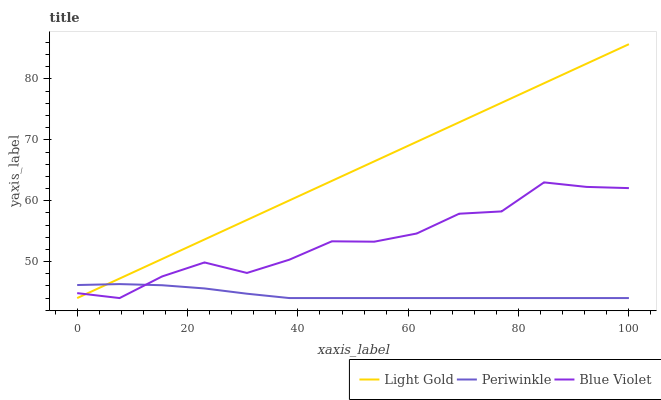Does Blue Violet have the minimum area under the curve?
Answer yes or no. No. Does Blue Violet have the maximum area under the curve?
Answer yes or no. No. Is Blue Violet the smoothest?
Answer yes or no. No. Is Light Gold the roughest?
Answer yes or no. No. Does Blue Violet have the highest value?
Answer yes or no. No. 